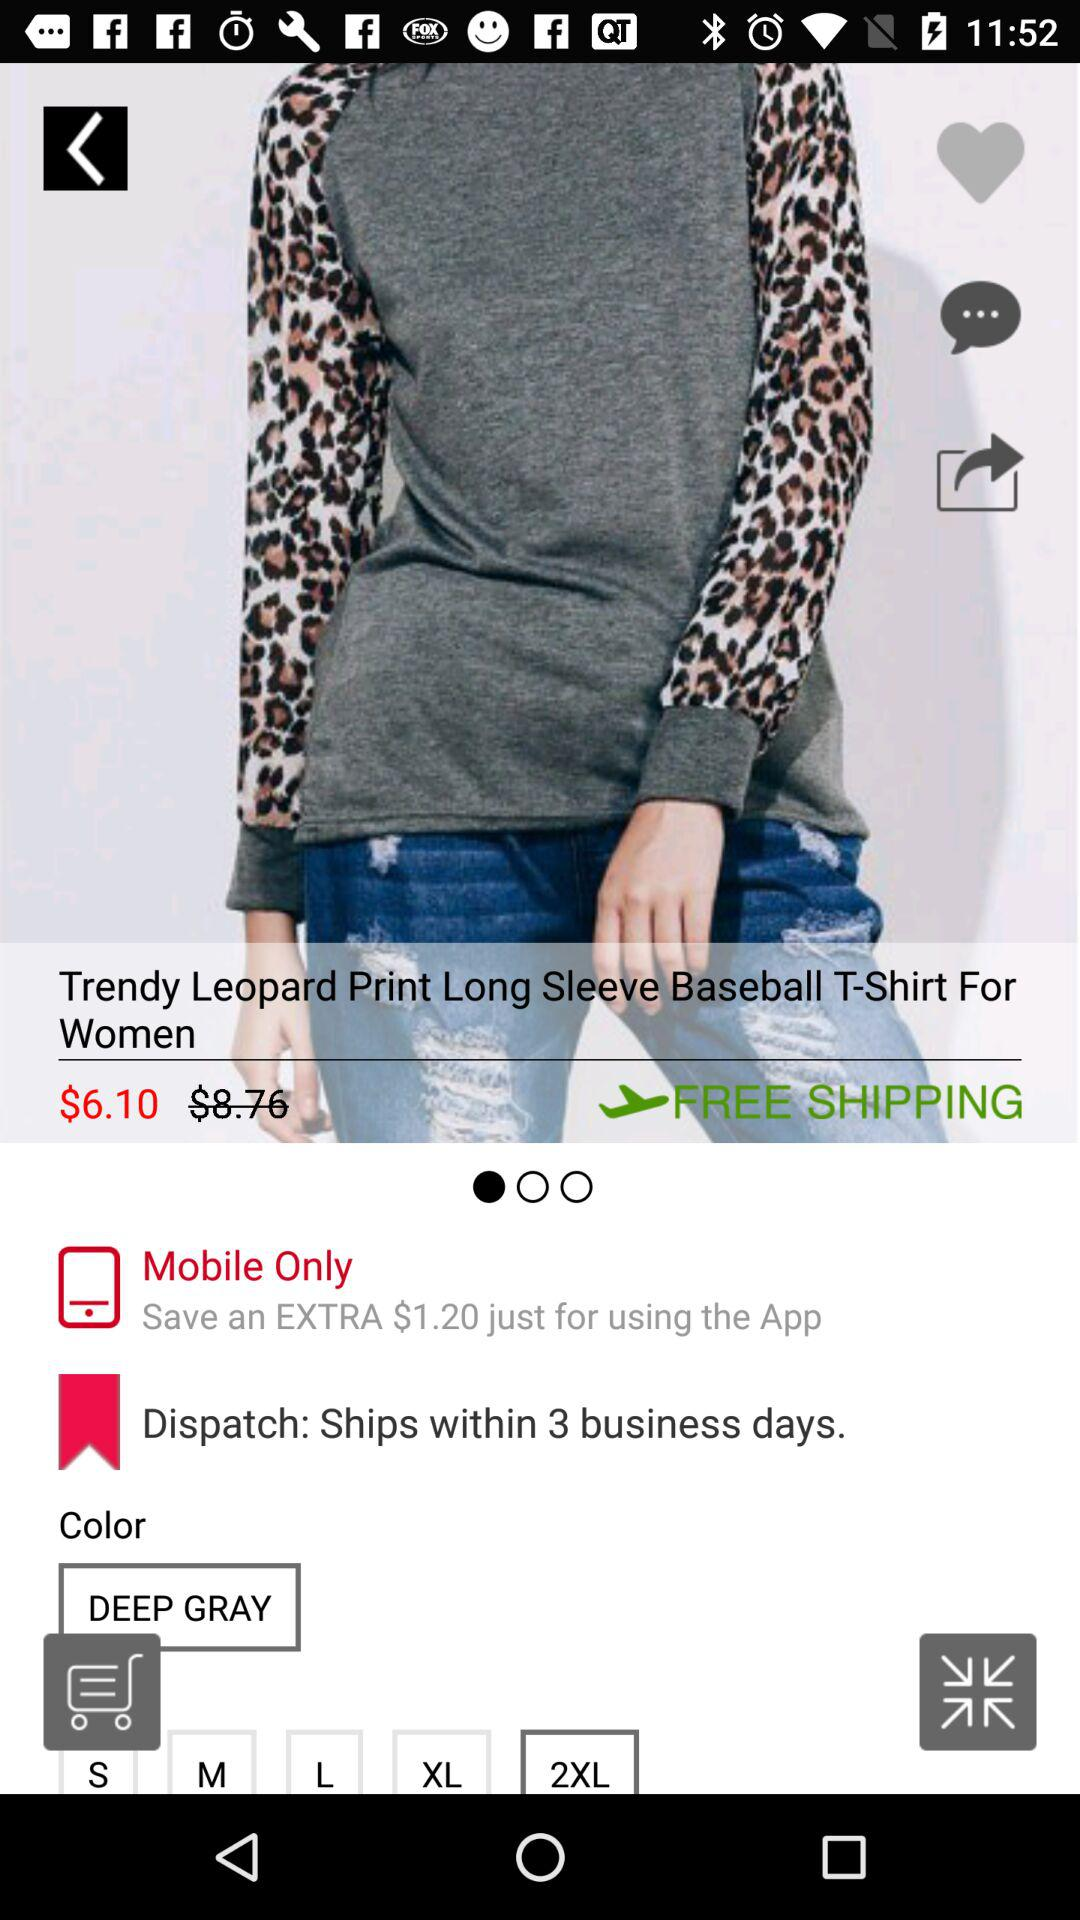What is the name of the product? The name of the product is "Trendy Leopard Print Long Sleeve Baseball T-Shirt For Women". 